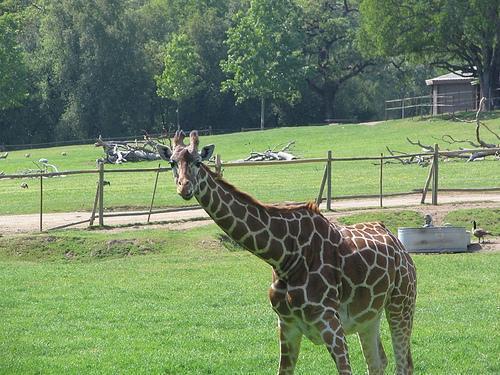How many giraffs in picture?
Give a very brief answer. 1. How many people is here?
Give a very brief answer. 0. 